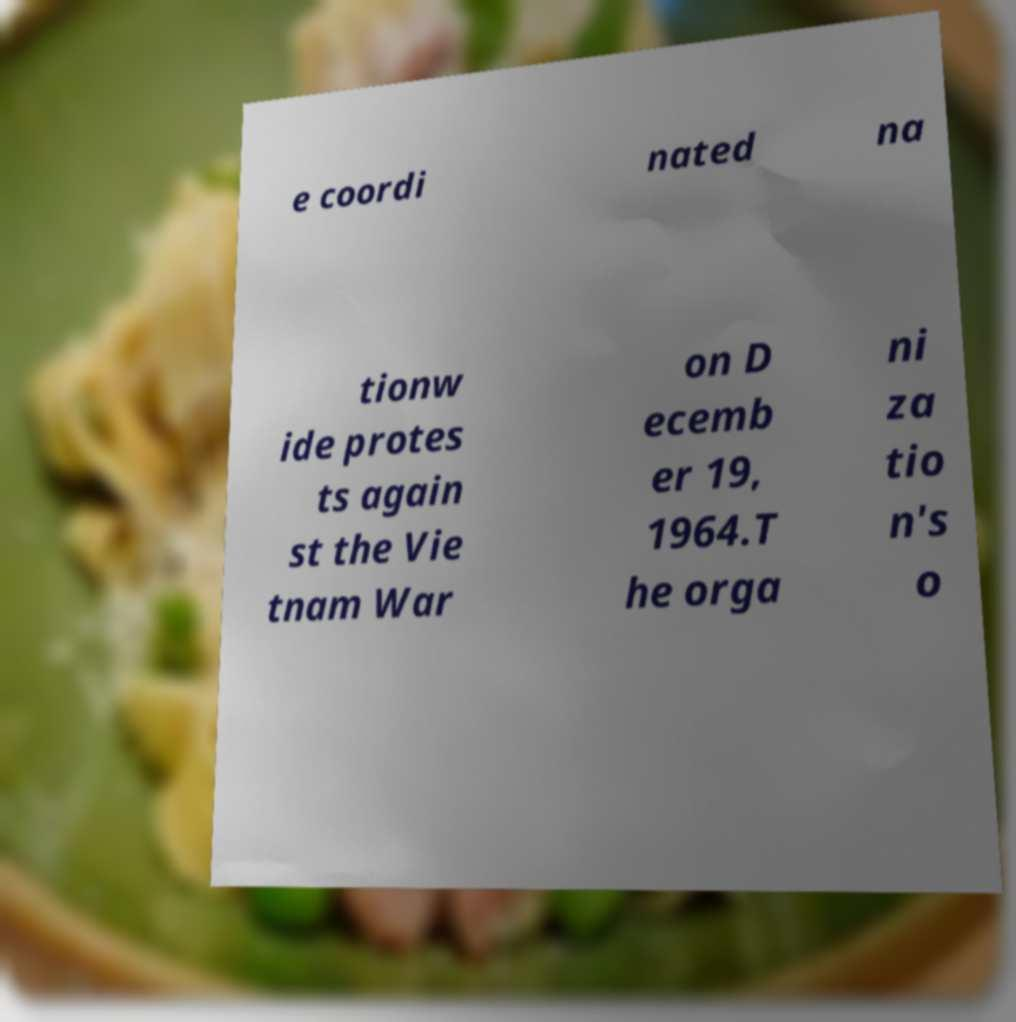I need the written content from this picture converted into text. Can you do that? e coordi nated na tionw ide protes ts again st the Vie tnam War on D ecemb er 19, 1964.T he orga ni za tio n's o 